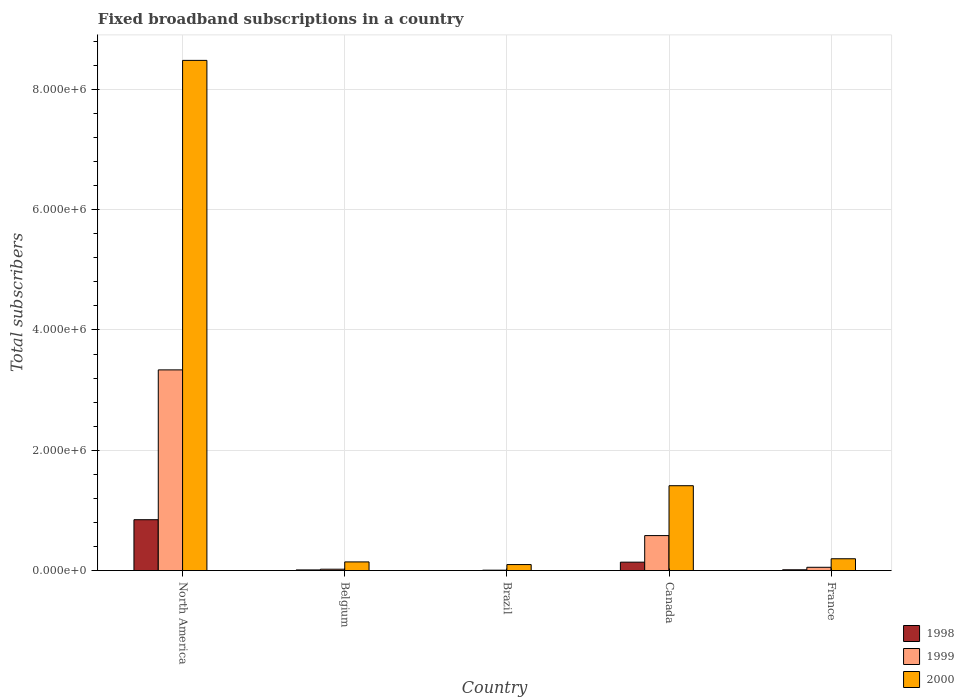Are the number of bars per tick equal to the number of legend labels?
Make the answer very short. Yes. How many bars are there on the 1st tick from the left?
Offer a very short reply. 3. How many bars are there on the 2nd tick from the right?
Keep it short and to the point. 3. What is the number of broadband subscriptions in 1999 in Brazil?
Make the answer very short. 7000. Across all countries, what is the maximum number of broadband subscriptions in 1998?
Provide a short and direct response. 8.46e+05. Across all countries, what is the minimum number of broadband subscriptions in 1998?
Your answer should be compact. 1000. In which country was the number of broadband subscriptions in 2000 maximum?
Provide a short and direct response. North America. In which country was the number of broadband subscriptions in 1999 minimum?
Make the answer very short. Brazil. What is the total number of broadband subscriptions in 1999 in the graph?
Offer a very short reply. 4.00e+06. What is the difference between the number of broadband subscriptions in 1998 in Belgium and that in Canada?
Offer a very short reply. -1.29e+05. What is the difference between the number of broadband subscriptions in 1999 in France and the number of broadband subscriptions in 2000 in North America?
Provide a succinct answer. -8.43e+06. What is the average number of broadband subscriptions in 1999 per country?
Ensure brevity in your answer.  8.01e+05. What is the difference between the number of broadband subscriptions of/in 1999 and number of broadband subscriptions of/in 1998 in Canada?
Provide a short and direct response. 4.42e+05. In how many countries, is the number of broadband subscriptions in 1999 greater than 8400000?
Your answer should be very brief. 0. What is the ratio of the number of broadband subscriptions in 1999 in Canada to that in North America?
Make the answer very short. 0.17. Is the difference between the number of broadband subscriptions in 1999 in Brazil and Canada greater than the difference between the number of broadband subscriptions in 1998 in Brazil and Canada?
Your answer should be very brief. No. What is the difference between the highest and the second highest number of broadband subscriptions in 1998?
Give a very brief answer. -7.06e+05. What is the difference between the highest and the lowest number of broadband subscriptions in 2000?
Give a very brief answer. 8.38e+06. What does the 2nd bar from the left in Canada represents?
Give a very brief answer. 1999. What does the 2nd bar from the right in North America represents?
Offer a terse response. 1999. How many bars are there?
Your response must be concise. 15. Are all the bars in the graph horizontal?
Offer a very short reply. No. How many countries are there in the graph?
Offer a terse response. 5. What is the difference between two consecutive major ticks on the Y-axis?
Provide a short and direct response. 2.00e+06. Does the graph contain grids?
Give a very brief answer. Yes. How are the legend labels stacked?
Make the answer very short. Vertical. What is the title of the graph?
Your answer should be very brief. Fixed broadband subscriptions in a country. What is the label or title of the Y-axis?
Your response must be concise. Total subscribers. What is the Total subscribers in 1998 in North America?
Provide a succinct answer. 8.46e+05. What is the Total subscribers in 1999 in North America?
Your answer should be compact. 3.34e+06. What is the Total subscribers in 2000 in North America?
Offer a terse response. 8.48e+06. What is the Total subscribers of 1998 in Belgium?
Offer a very short reply. 1.09e+04. What is the Total subscribers of 1999 in Belgium?
Give a very brief answer. 2.30e+04. What is the Total subscribers of 2000 in Belgium?
Provide a short and direct response. 1.44e+05. What is the Total subscribers in 1999 in Brazil?
Provide a short and direct response. 7000. What is the Total subscribers of 2000 in Brazil?
Give a very brief answer. 1.00e+05. What is the Total subscribers of 1998 in Canada?
Make the answer very short. 1.40e+05. What is the Total subscribers in 1999 in Canada?
Provide a succinct answer. 5.82e+05. What is the Total subscribers of 2000 in Canada?
Your answer should be very brief. 1.41e+06. What is the Total subscribers in 1998 in France?
Your answer should be very brief. 1.35e+04. What is the Total subscribers in 1999 in France?
Offer a very short reply. 5.50e+04. What is the Total subscribers of 2000 in France?
Your response must be concise. 1.97e+05. Across all countries, what is the maximum Total subscribers of 1998?
Ensure brevity in your answer.  8.46e+05. Across all countries, what is the maximum Total subscribers of 1999?
Your answer should be very brief. 3.34e+06. Across all countries, what is the maximum Total subscribers in 2000?
Your answer should be compact. 8.48e+06. Across all countries, what is the minimum Total subscribers of 1999?
Offer a terse response. 7000. Across all countries, what is the minimum Total subscribers in 2000?
Give a very brief answer. 1.00e+05. What is the total Total subscribers of 1998 in the graph?
Offer a terse response. 1.01e+06. What is the total Total subscribers in 1999 in the graph?
Provide a short and direct response. 4.00e+06. What is the total Total subscribers in 2000 in the graph?
Your answer should be very brief. 1.03e+07. What is the difference between the Total subscribers in 1998 in North America and that in Belgium?
Keep it short and to the point. 8.35e+05. What is the difference between the Total subscribers of 1999 in North America and that in Belgium?
Make the answer very short. 3.31e+06. What is the difference between the Total subscribers in 2000 in North America and that in Belgium?
Provide a short and direct response. 8.34e+06. What is the difference between the Total subscribers of 1998 in North America and that in Brazil?
Ensure brevity in your answer.  8.45e+05. What is the difference between the Total subscribers in 1999 in North America and that in Brazil?
Ensure brevity in your answer.  3.33e+06. What is the difference between the Total subscribers in 2000 in North America and that in Brazil?
Your answer should be very brief. 8.38e+06. What is the difference between the Total subscribers of 1998 in North America and that in Canada?
Ensure brevity in your answer.  7.06e+05. What is the difference between the Total subscribers in 1999 in North America and that in Canada?
Your answer should be compact. 2.75e+06. What is the difference between the Total subscribers in 2000 in North America and that in Canada?
Give a very brief answer. 7.07e+06. What is the difference between the Total subscribers of 1998 in North America and that in France?
Your answer should be very brief. 8.32e+05. What is the difference between the Total subscribers in 1999 in North America and that in France?
Provide a succinct answer. 3.28e+06. What is the difference between the Total subscribers of 2000 in North America and that in France?
Your answer should be compact. 8.28e+06. What is the difference between the Total subscribers of 1998 in Belgium and that in Brazil?
Provide a short and direct response. 9924. What is the difference between the Total subscribers in 1999 in Belgium and that in Brazil?
Your answer should be compact. 1.60e+04. What is the difference between the Total subscribers in 2000 in Belgium and that in Brazil?
Offer a very short reply. 4.42e+04. What is the difference between the Total subscribers in 1998 in Belgium and that in Canada?
Your response must be concise. -1.29e+05. What is the difference between the Total subscribers in 1999 in Belgium and that in Canada?
Keep it short and to the point. -5.59e+05. What is the difference between the Total subscribers in 2000 in Belgium and that in Canada?
Make the answer very short. -1.27e+06. What is the difference between the Total subscribers in 1998 in Belgium and that in France?
Make the answer very short. -2540. What is the difference between the Total subscribers in 1999 in Belgium and that in France?
Ensure brevity in your answer.  -3.20e+04. What is the difference between the Total subscribers in 2000 in Belgium and that in France?
Your answer should be compact. -5.24e+04. What is the difference between the Total subscribers of 1998 in Brazil and that in Canada?
Ensure brevity in your answer.  -1.39e+05. What is the difference between the Total subscribers in 1999 in Brazil and that in Canada?
Offer a terse response. -5.75e+05. What is the difference between the Total subscribers in 2000 in Brazil and that in Canada?
Your answer should be compact. -1.31e+06. What is the difference between the Total subscribers in 1998 in Brazil and that in France?
Provide a succinct answer. -1.25e+04. What is the difference between the Total subscribers in 1999 in Brazil and that in France?
Offer a terse response. -4.80e+04. What is the difference between the Total subscribers of 2000 in Brazil and that in France?
Provide a short and direct response. -9.66e+04. What is the difference between the Total subscribers in 1998 in Canada and that in France?
Your response must be concise. 1.27e+05. What is the difference between the Total subscribers in 1999 in Canada and that in France?
Your answer should be very brief. 5.27e+05. What is the difference between the Total subscribers of 2000 in Canada and that in France?
Provide a short and direct response. 1.21e+06. What is the difference between the Total subscribers in 1998 in North America and the Total subscribers in 1999 in Belgium?
Keep it short and to the point. 8.23e+05. What is the difference between the Total subscribers in 1998 in North America and the Total subscribers in 2000 in Belgium?
Keep it short and to the point. 7.02e+05. What is the difference between the Total subscribers of 1999 in North America and the Total subscribers of 2000 in Belgium?
Ensure brevity in your answer.  3.19e+06. What is the difference between the Total subscribers in 1998 in North America and the Total subscribers in 1999 in Brazil?
Provide a succinct answer. 8.39e+05. What is the difference between the Total subscribers in 1998 in North America and the Total subscribers in 2000 in Brazil?
Give a very brief answer. 7.46e+05. What is the difference between the Total subscribers in 1999 in North America and the Total subscribers in 2000 in Brazil?
Keep it short and to the point. 3.24e+06. What is the difference between the Total subscribers in 1998 in North America and the Total subscribers in 1999 in Canada?
Provide a succinct answer. 2.64e+05. What is the difference between the Total subscribers of 1998 in North America and the Total subscribers of 2000 in Canada?
Give a very brief answer. -5.65e+05. What is the difference between the Total subscribers of 1999 in North America and the Total subscribers of 2000 in Canada?
Make the answer very short. 1.93e+06. What is the difference between the Total subscribers of 1998 in North America and the Total subscribers of 1999 in France?
Give a very brief answer. 7.91e+05. What is the difference between the Total subscribers of 1998 in North America and the Total subscribers of 2000 in France?
Your response must be concise. 6.49e+05. What is the difference between the Total subscribers of 1999 in North America and the Total subscribers of 2000 in France?
Offer a very short reply. 3.14e+06. What is the difference between the Total subscribers in 1998 in Belgium and the Total subscribers in 1999 in Brazil?
Make the answer very short. 3924. What is the difference between the Total subscribers of 1998 in Belgium and the Total subscribers of 2000 in Brazil?
Keep it short and to the point. -8.91e+04. What is the difference between the Total subscribers of 1999 in Belgium and the Total subscribers of 2000 in Brazil?
Offer a very short reply. -7.70e+04. What is the difference between the Total subscribers of 1998 in Belgium and the Total subscribers of 1999 in Canada?
Make the answer very short. -5.71e+05. What is the difference between the Total subscribers in 1998 in Belgium and the Total subscribers in 2000 in Canada?
Offer a very short reply. -1.40e+06. What is the difference between the Total subscribers of 1999 in Belgium and the Total subscribers of 2000 in Canada?
Your answer should be compact. -1.39e+06. What is the difference between the Total subscribers in 1998 in Belgium and the Total subscribers in 1999 in France?
Your answer should be very brief. -4.41e+04. What is the difference between the Total subscribers of 1998 in Belgium and the Total subscribers of 2000 in France?
Your answer should be very brief. -1.86e+05. What is the difference between the Total subscribers of 1999 in Belgium and the Total subscribers of 2000 in France?
Your answer should be very brief. -1.74e+05. What is the difference between the Total subscribers in 1998 in Brazil and the Total subscribers in 1999 in Canada?
Keep it short and to the point. -5.81e+05. What is the difference between the Total subscribers of 1998 in Brazil and the Total subscribers of 2000 in Canada?
Provide a short and direct response. -1.41e+06. What is the difference between the Total subscribers in 1999 in Brazil and the Total subscribers in 2000 in Canada?
Provide a short and direct response. -1.40e+06. What is the difference between the Total subscribers in 1998 in Brazil and the Total subscribers in 1999 in France?
Keep it short and to the point. -5.40e+04. What is the difference between the Total subscribers in 1998 in Brazil and the Total subscribers in 2000 in France?
Provide a short and direct response. -1.96e+05. What is the difference between the Total subscribers of 1999 in Brazil and the Total subscribers of 2000 in France?
Provide a short and direct response. -1.90e+05. What is the difference between the Total subscribers in 1998 in Canada and the Total subscribers in 1999 in France?
Keep it short and to the point. 8.50e+04. What is the difference between the Total subscribers of 1998 in Canada and the Total subscribers of 2000 in France?
Give a very brief answer. -5.66e+04. What is the difference between the Total subscribers in 1999 in Canada and the Total subscribers in 2000 in France?
Your answer should be compact. 3.85e+05. What is the average Total subscribers in 1998 per country?
Your answer should be compact. 2.02e+05. What is the average Total subscribers in 1999 per country?
Give a very brief answer. 8.01e+05. What is the average Total subscribers in 2000 per country?
Your response must be concise. 2.07e+06. What is the difference between the Total subscribers in 1998 and Total subscribers in 1999 in North America?
Make the answer very short. -2.49e+06. What is the difference between the Total subscribers in 1998 and Total subscribers in 2000 in North America?
Keep it short and to the point. -7.63e+06. What is the difference between the Total subscribers of 1999 and Total subscribers of 2000 in North America?
Your response must be concise. -5.14e+06. What is the difference between the Total subscribers in 1998 and Total subscribers in 1999 in Belgium?
Provide a short and direct response. -1.21e+04. What is the difference between the Total subscribers in 1998 and Total subscribers in 2000 in Belgium?
Your answer should be very brief. -1.33e+05. What is the difference between the Total subscribers of 1999 and Total subscribers of 2000 in Belgium?
Provide a short and direct response. -1.21e+05. What is the difference between the Total subscribers of 1998 and Total subscribers of 1999 in Brazil?
Provide a succinct answer. -6000. What is the difference between the Total subscribers in 1998 and Total subscribers in 2000 in Brazil?
Your response must be concise. -9.90e+04. What is the difference between the Total subscribers in 1999 and Total subscribers in 2000 in Brazil?
Offer a terse response. -9.30e+04. What is the difference between the Total subscribers in 1998 and Total subscribers in 1999 in Canada?
Make the answer very short. -4.42e+05. What is the difference between the Total subscribers in 1998 and Total subscribers in 2000 in Canada?
Make the answer very short. -1.27e+06. What is the difference between the Total subscribers of 1999 and Total subscribers of 2000 in Canada?
Your answer should be compact. -8.29e+05. What is the difference between the Total subscribers in 1998 and Total subscribers in 1999 in France?
Offer a very short reply. -4.15e+04. What is the difference between the Total subscribers of 1998 and Total subscribers of 2000 in France?
Your response must be concise. -1.83e+05. What is the difference between the Total subscribers in 1999 and Total subscribers in 2000 in France?
Your response must be concise. -1.42e+05. What is the ratio of the Total subscribers in 1998 in North America to that in Belgium?
Your answer should be very brief. 77.44. What is the ratio of the Total subscribers of 1999 in North America to that in Belgium?
Provide a succinct answer. 145.06. What is the ratio of the Total subscribers of 2000 in North America to that in Belgium?
Offer a terse response. 58.81. What is the ratio of the Total subscribers in 1998 in North America to that in Brazil?
Your answer should be very brief. 845.9. What is the ratio of the Total subscribers of 1999 in North America to that in Brazil?
Your answer should be compact. 476.61. What is the ratio of the Total subscribers of 2000 in North America to that in Brazil?
Provide a short and direct response. 84.81. What is the ratio of the Total subscribers in 1998 in North America to that in Canada?
Your answer should be compact. 6.04. What is the ratio of the Total subscribers of 1999 in North America to that in Canada?
Offer a terse response. 5.73. What is the ratio of the Total subscribers of 2000 in North America to that in Canada?
Your answer should be compact. 6.01. What is the ratio of the Total subscribers in 1998 in North America to that in France?
Provide a short and direct response. 62.83. What is the ratio of the Total subscribers of 1999 in North America to that in France?
Ensure brevity in your answer.  60.66. What is the ratio of the Total subscribers of 2000 in North America to that in France?
Offer a very short reply. 43.14. What is the ratio of the Total subscribers of 1998 in Belgium to that in Brazil?
Offer a very short reply. 10.92. What is the ratio of the Total subscribers of 1999 in Belgium to that in Brazil?
Offer a very short reply. 3.29. What is the ratio of the Total subscribers in 2000 in Belgium to that in Brazil?
Make the answer very short. 1.44. What is the ratio of the Total subscribers of 1998 in Belgium to that in Canada?
Provide a succinct answer. 0.08. What is the ratio of the Total subscribers in 1999 in Belgium to that in Canada?
Keep it short and to the point. 0.04. What is the ratio of the Total subscribers of 2000 in Belgium to that in Canada?
Provide a succinct answer. 0.1. What is the ratio of the Total subscribers in 1998 in Belgium to that in France?
Ensure brevity in your answer.  0.81. What is the ratio of the Total subscribers of 1999 in Belgium to that in France?
Provide a short and direct response. 0.42. What is the ratio of the Total subscribers in 2000 in Belgium to that in France?
Offer a very short reply. 0.73. What is the ratio of the Total subscribers in 1998 in Brazil to that in Canada?
Provide a succinct answer. 0.01. What is the ratio of the Total subscribers of 1999 in Brazil to that in Canada?
Offer a terse response. 0.01. What is the ratio of the Total subscribers in 2000 in Brazil to that in Canada?
Make the answer very short. 0.07. What is the ratio of the Total subscribers in 1998 in Brazil to that in France?
Provide a succinct answer. 0.07. What is the ratio of the Total subscribers of 1999 in Brazil to that in France?
Make the answer very short. 0.13. What is the ratio of the Total subscribers of 2000 in Brazil to that in France?
Make the answer very short. 0.51. What is the ratio of the Total subscribers in 1998 in Canada to that in France?
Keep it short and to the point. 10.4. What is the ratio of the Total subscribers of 1999 in Canada to that in France?
Make the answer very short. 10.58. What is the ratio of the Total subscribers of 2000 in Canada to that in France?
Keep it short and to the point. 7.18. What is the difference between the highest and the second highest Total subscribers of 1998?
Provide a short and direct response. 7.06e+05. What is the difference between the highest and the second highest Total subscribers of 1999?
Give a very brief answer. 2.75e+06. What is the difference between the highest and the second highest Total subscribers in 2000?
Give a very brief answer. 7.07e+06. What is the difference between the highest and the lowest Total subscribers of 1998?
Keep it short and to the point. 8.45e+05. What is the difference between the highest and the lowest Total subscribers of 1999?
Your response must be concise. 3.33e+06. What is the difference between the highest and the lowest Total subscribers of 2000?
Keep it short and to the point. 8.38e+06. 